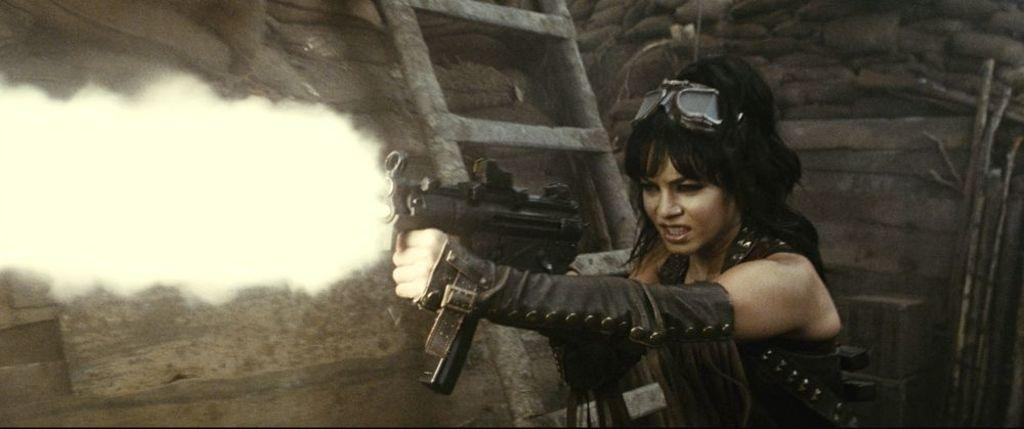Who is present in the image? There is a man in the image. What is the man holding in his hand? The man is holding a gun in his hand. What can be seen on the right side of the image? There are sticks on the right side of the image. What objects are visible in the background of the image? Gunny bags and a ladder are present in the background of the image. How many girls are speaking a different language in the image? There are no girls or any indication of language spoken in the image. 